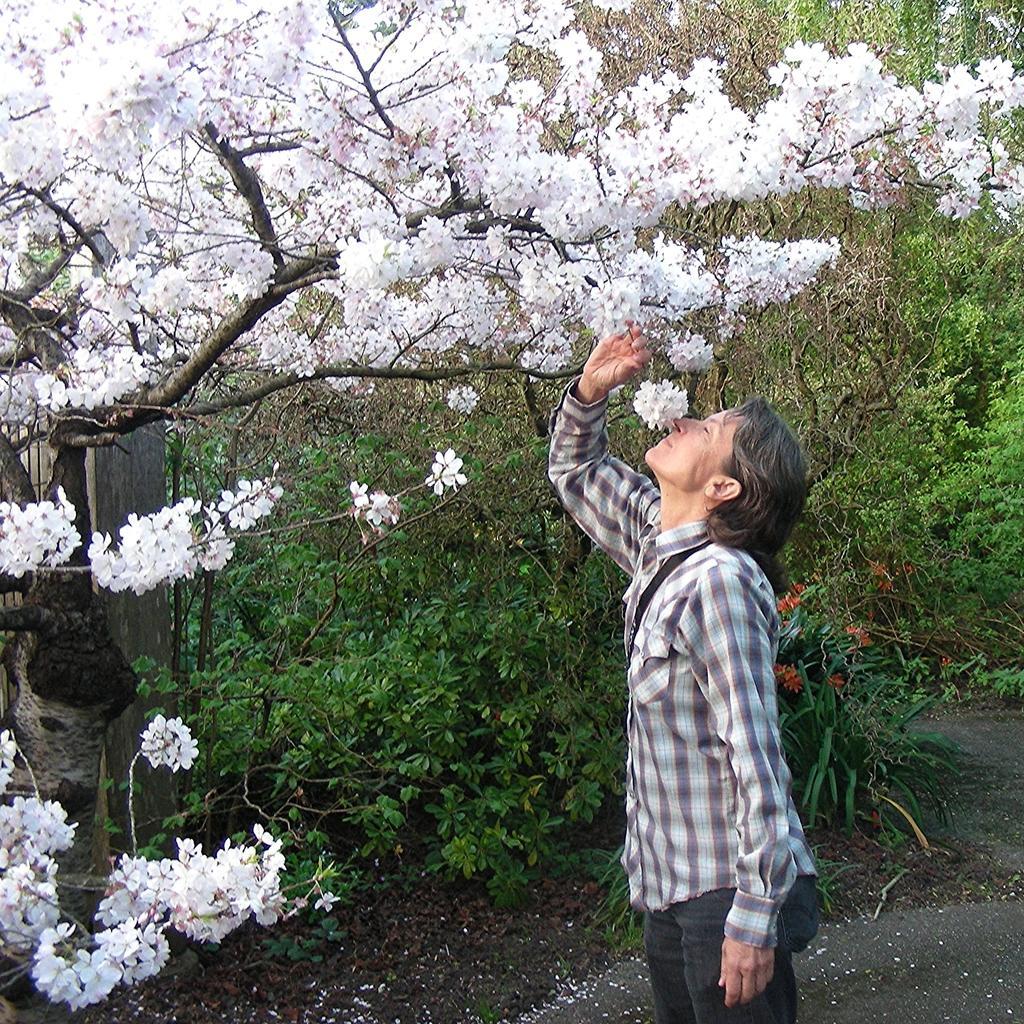Please provide a concise description of this image. In the image I can see a person who is holding the flower of a tree to which there are some flowers which are in white color and around there are some other trees and plants. 